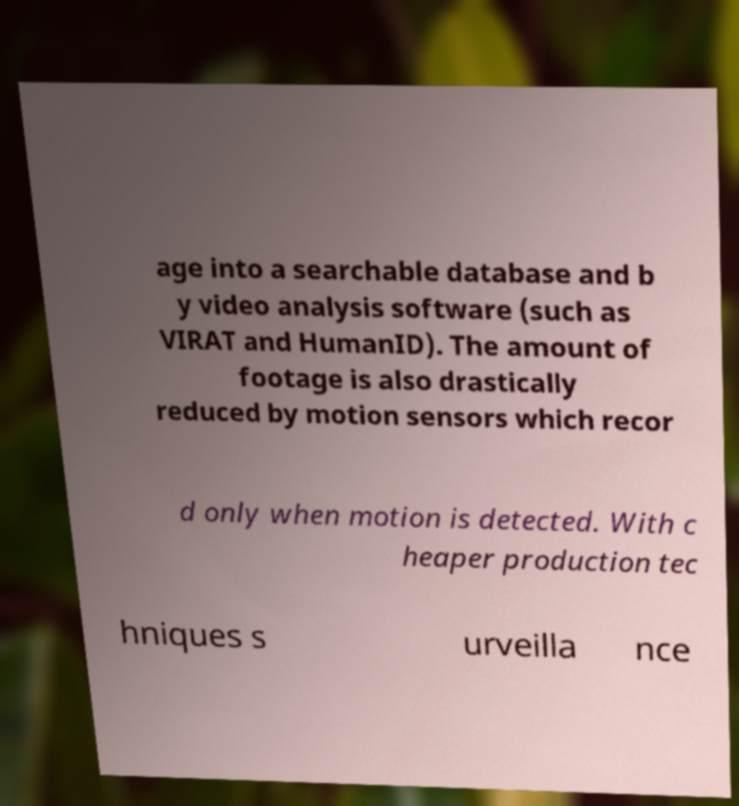Could you assist in decoding the text presented in this image and type it out clearly? age into a searchable database and b y video analysis software (such as VIRAT and HumanID). The amount of footage is also drastically reduced by motion sensors which recor d only when motion is detected. With c heaper production tec hniques s urveilla nce 